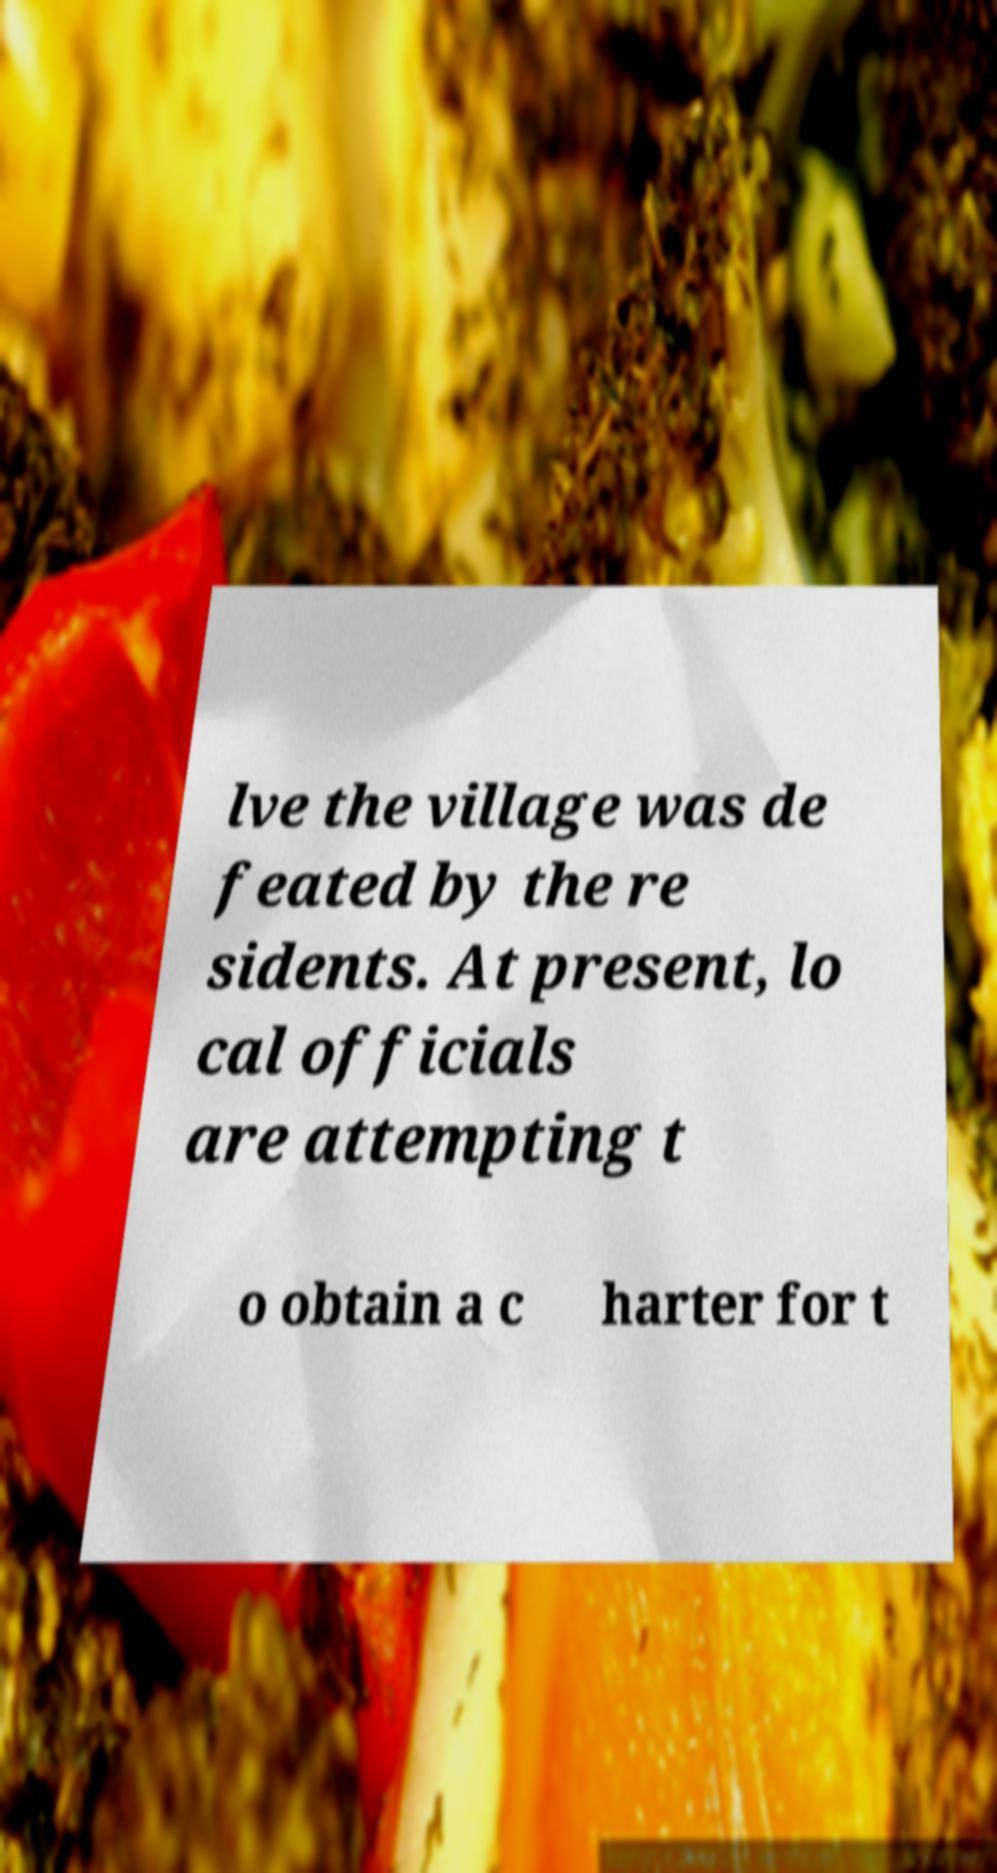Can you accurately transcribe the text from the provided image for me? lve the village was de feated by the re sidents. At present, lo cal officials are attempting t o obtain a c harter for t 